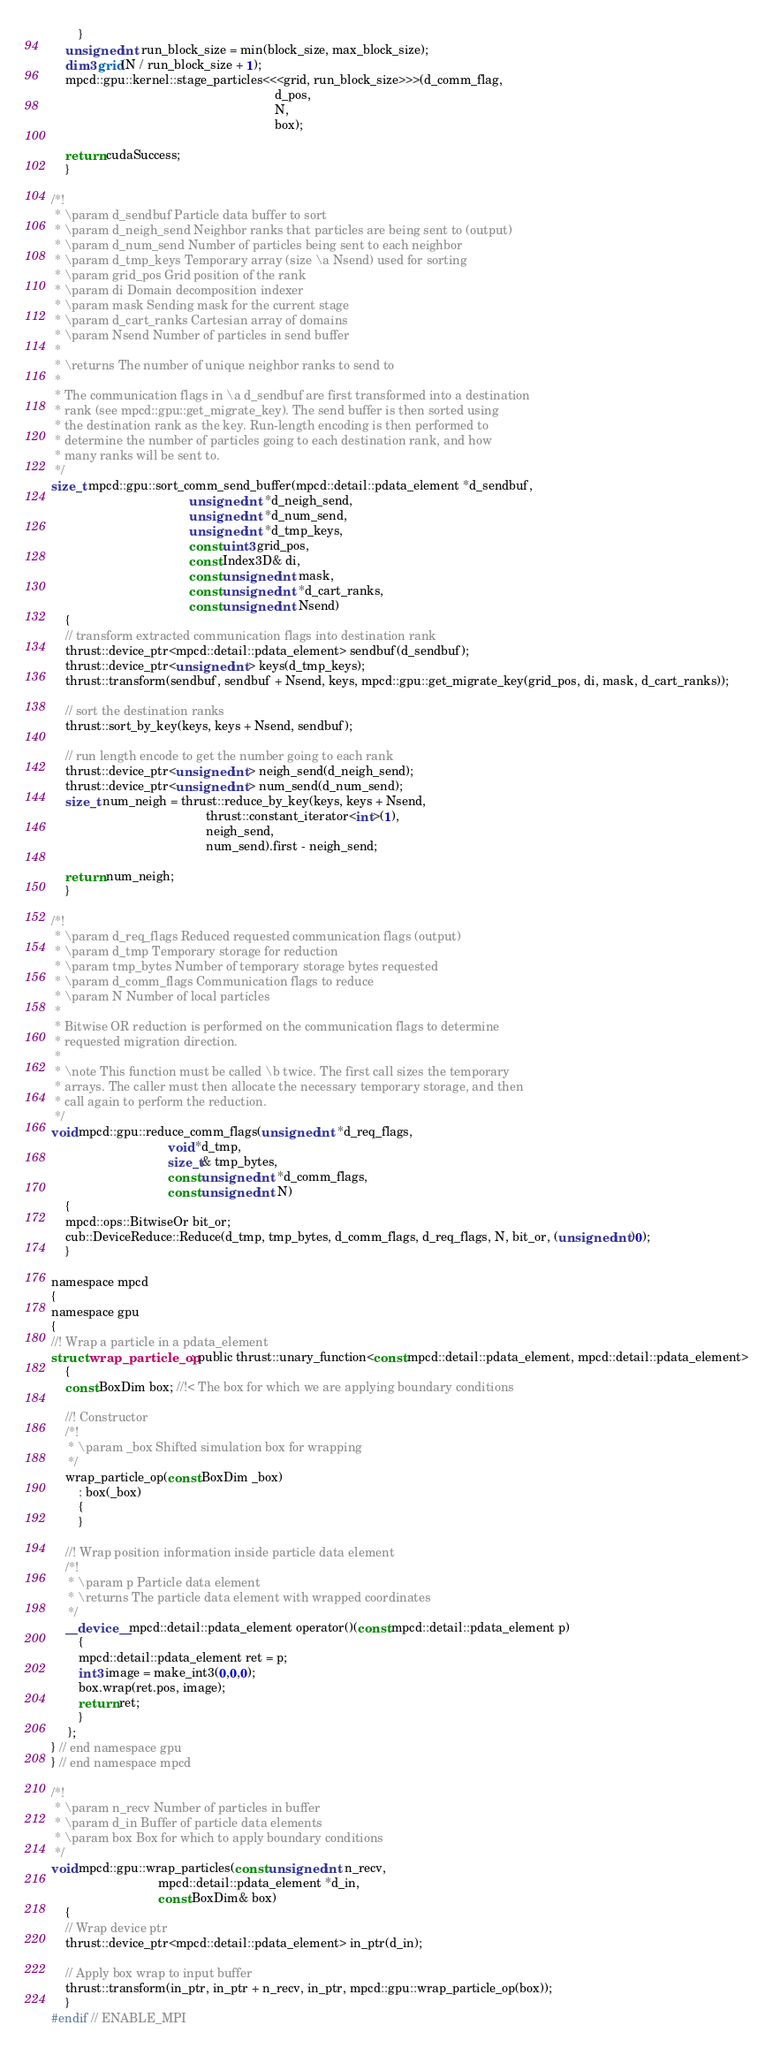<code> <loc_0><loc_0><loc_500><loc_500><_Cuda_>        }
    unsigned int run_block_size = min(block_size, max_block_size);
    dim3 grid(N / run_block_size + 1);
    mpcd::gpu::kernel::stage_particles<<<grid, run_block_size>>>(d_comm_flag,
                                                                 d_pos,
                                                                 N,
                                                                 box);

    return cudaSuccess;
    }

/*!
 * \param d_sendbuf Particle data buffer to sort
 * \param d_neigh_send Neighbor ranks that particles are being sent to (output)
 * \param d_num_send Number of particles being sent to each neighbor
 * \param d_tmp_keys Temporary array (size \a Nsend) used for sorting
 * \param grid_pos Grid position of the rank
 * \param di Domain decomposition indexer
 * \param mask Sending mask for the current stage
 * \param d_cart_ranks Cartesian array of domains
 * \param Nsend Number of particles in send buffer
 *
 * \returns The number of unique neighbor ranks to send to
 *
 * The communication flags in \a d_sendbuf are first transformed into a destination
 * rank (see mpcd::gpu::get_migrate_key). The send buffer is then sorted using
 * the destination rank as the key. Run-length encoding is then performed to
 * determine the number of particles going to each destination rank, and how
 * many ranks will be sent to.
 */
size_t mpcd::gpu::sort_comm_send_buffer(mpcd::detail::pdata_element *d_sendbuf,
                                        unsigned int *d_neigh_send,
                                        unsigned int *d_num_send,
                                        unsigned int *d_tmp_keys,
                                        const uint3 grid_pos,
                                        const Index3D& di,
                                        const unsigned int mask,
                                        const unsigned int *d_cart_ranks,
                                        const unsigned int Nsend)
    {
    // transform extracted communication flags into destination rank
    thrust::device_ptr<mpcd::detail::pdata_element> sendbuf(d_sendbuf);
    thrust::device_ptr<unsigned int> keys(d_tmp_keys);
    thrust::transform(sendbuf, sendbuf + Nsend, keys, mpcd::gpu::get_migrate_key(grid_pos, di, mask, d_cart_ranks));

    // sort the destination ranks
    thrust::sort_by_key(keys, keys + Nsend, sendbuf);

    // run length encode to get the number going to each rank
    thrust::device_ptr<unsigned int> neigh_send(d_neigh_send);
    thrust::device_ptr<unsigned int> num_send(d_num_send);
    size_t num_neigh = thrust::reduce_by_key(keys, keys + Nsend,
                                             thrust::constant_iterator<int>(1),
                                             neigh_send,
                                             num_send).first - neigh_send;

    return num_neigh;
    }

/*!
 * \param d_req_flags Reduced requested communication flags (output)
 * \param d_tmp Temporary storage for reduction
 * \param tmp_bytes Number of temporary storage bytes requested
 * \param d_comm_flags Communication flags to reduce
 * \param N Number of local particles
 *
 * Bitwise OR reduction is performed on the communication flags to determine
 * requested migration direction.
 *
 * \note This function must be called \b twice. The first call sizes the temporary
 * arrays. The caller must then allocate the necessary temporary storage, and then
 * call again to perform the reduction.
 */
void mpcd::gpu::reduce_comm_flags(unsigned int *d_req_flags,
                                  void *d_tmp,
                                  size_t& tmp_bytes,
                                  const unsigned int *d_comm_flags,
                                  const unsigned int N)
    {
    mpcd::ops::BitwiseOr bit_or;
    cub::DeviceReduce::Reduce(d_tmp, tmp_bytes, d_comm_flags, d_req_flags, N, bit_or, (unsigned int)0);
    }

namespace mpcd
{
namespace gpu
{
//! Wrap a particle in a pdata_element
struct wrap_particle_op : public thrust::unary_function<const mpcd::detail::pdata_element, mpcd::detail::pdata_element>
    {
    const BoxDim box; //!< The box for which we are applying boundary conditions

    //! Constructor
    /*!
     * \param _box Shifted simulation box for wrapping
     */
    wrap_particle_op(const BoxDim _box)
        : box(_box)
        {
        }

    //! Wrap position information inside particle data element
    /*!
     * \param p Particle data element
     * \returns The particle data element with wrapped coordinates
     */
    __device__ mpcd::detail::pdata_element operator()(const mpcd::detail::pdata_element p)
        {
        mpcd::detail::pdata_element ret = p;
        int3 image = make_int3(0,0,0);
        box.wrap(ret.pos, image);
        return ret;
        }
     };
} // end namespace gpu
} // end namespace mpcd

/*!
 * \param n_recv Number of particles in buffer
 * \param d_in Buffer of particle data elements
 * \param box Box for which to apply boundary conditions
 */
void mpcd::gpu::wrap_particles(const unsigned int n_recv,
                               mpcd::detail::pdata_element *d_in,
                               const BoxDim& box)
    {
    // Wrap device ptr
    thrust::device_ptr<mpcd::detail::pdata_element> in_ptr(d_in);

    // Apply box wrap to input buffer
    thrust::transform(in_ptr, in_ptr + n_recv, in_ptr, mpcd::gpu::wrap_particle_op(box));
    }
#endif // ENABLE_MPI
</code> 